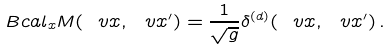<formula> <loc_0><loc_0><loc_500><loc_500>\ B c a l _ { x } M ( \ v x , \ v x ^ { \prime } ) = \frac { 1 } { \sqrt { g } } \delta ^ { ( d ) } ( \ v x , \ v x ^ { \prime } ) \, .</formula> 